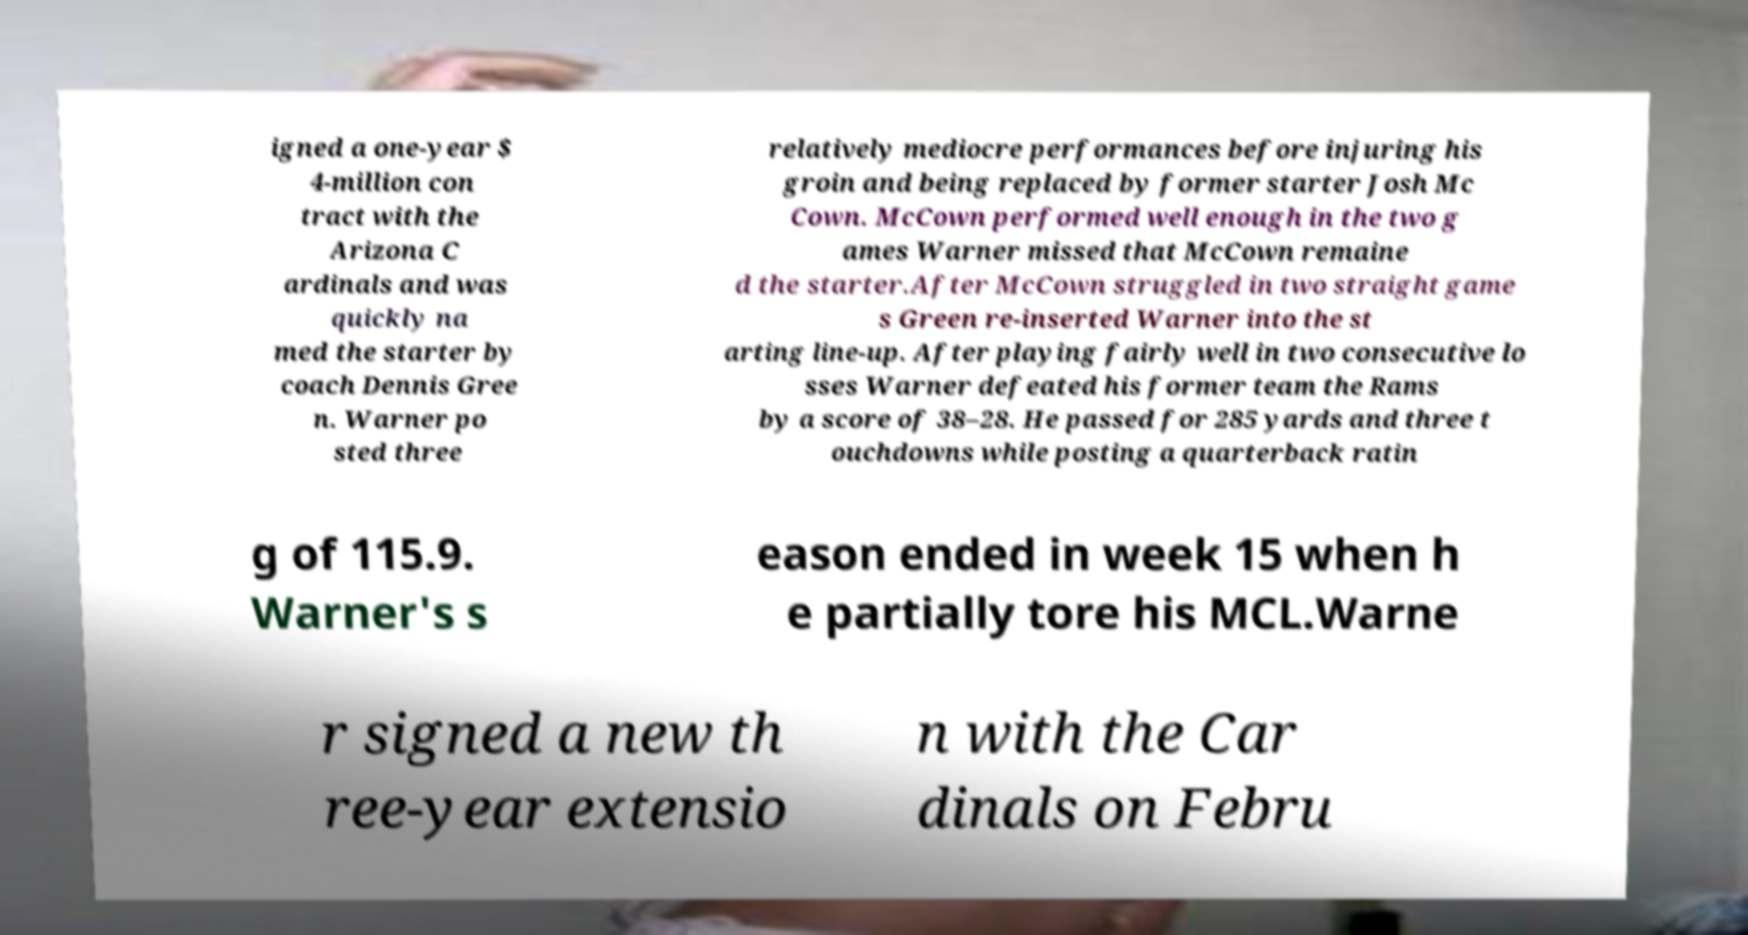For documentation purposes, I need the text within this image transcribed. Could you provide that? igned a one-year $ 4-million con tract with the Arizona C ardinals and was quickly na med the starter by coach Dennis Gree n. Warner po sted three relatively mediocre performances before injuring his groin and being replaced by former starter Josh Mc Cown. McCown performed well enough in the two g ames Warner missed that McCown remaine d the starter.After McCown struggled in two straight game s Green re-inserted Warner into the st arting line-up. After playing fairly well in two consecutive lo sses Warner defeated his former team the Rams by a score of 38–28. He passed for 285 yards and three t ouchdowns while posting a quarterback ratin g of 115.9. Warner's s eason ended in week 15 when h e partially tore his MCL.Warne r signed a new th ree-year extensio n with the Car dinals on Febru 